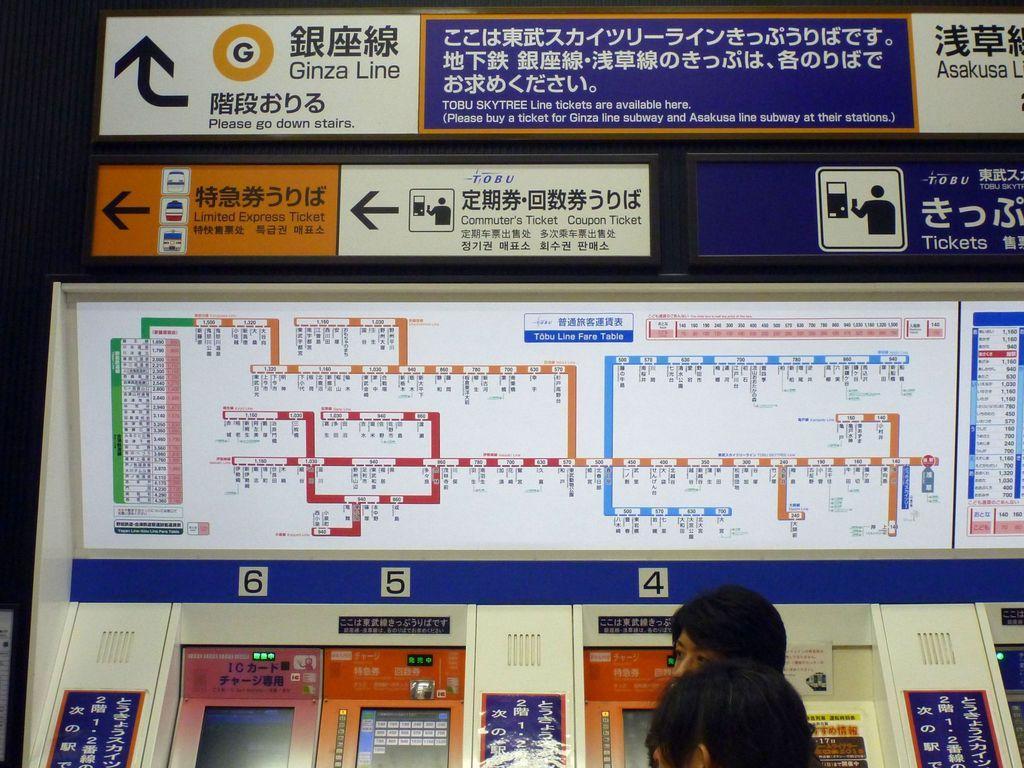Please provide a concise description of this image. In this image we can see electronic machines, beside that we can see a few people standing. And we can see text written on the board. 